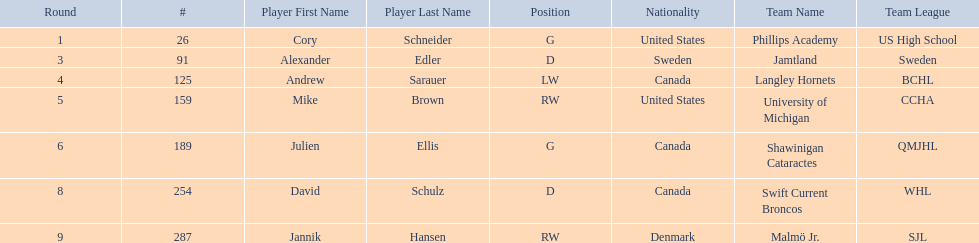What are the nationalities of the players? United States, Sweden, Canada, United States, Canada, Canada, Denmark. Of the players, which one lists his nationality as denmark? Jannik Hansen (RW). 